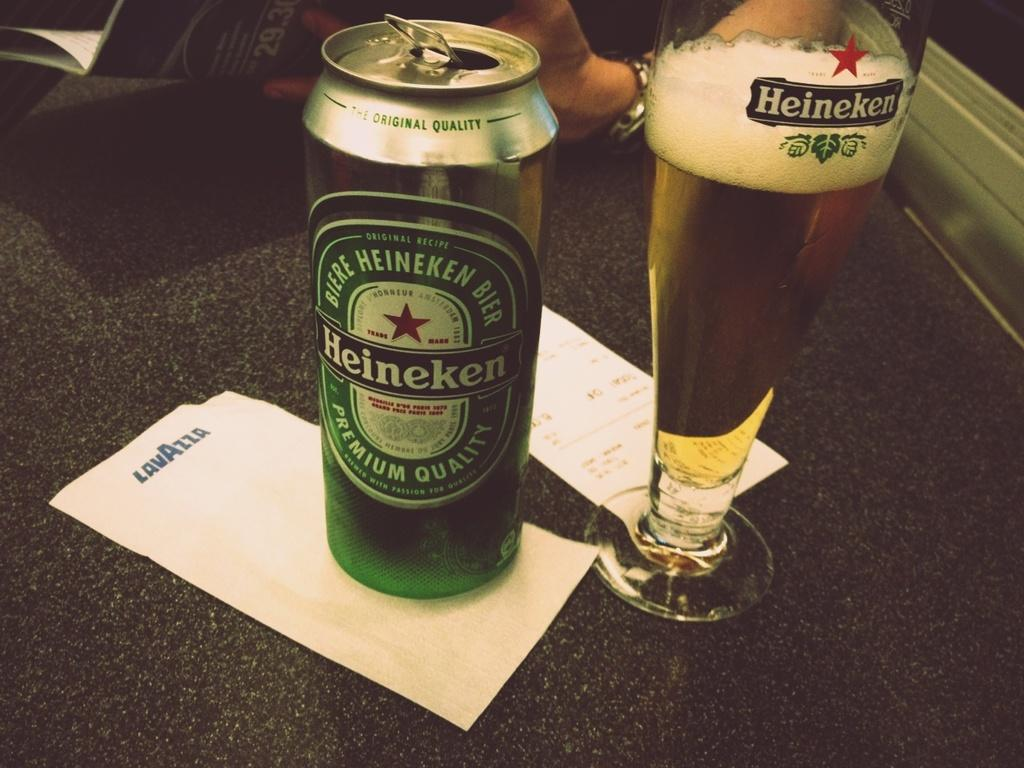<image>
Give a short and clear explanation of the subsequent image. A tall can of Heinekan next to a fresh pour in a Heinekan glass 